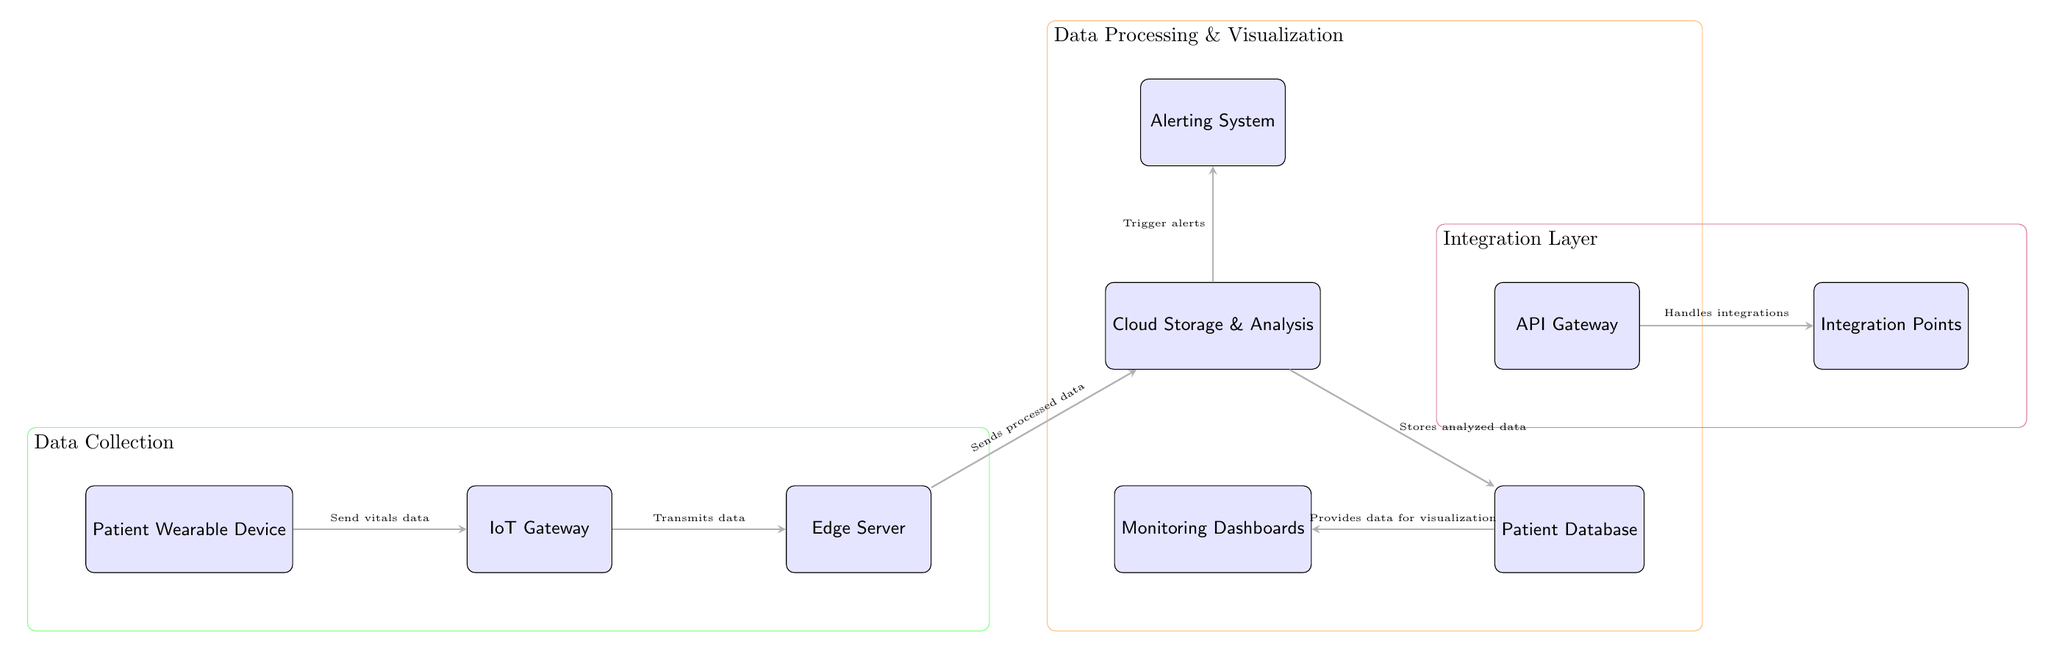What is the first component in the data flow? The first component in the data flow, shown in the diagram, is the "Patient Wearable Device," which initiates the transmission of vitals data.
Answer: Patient Wearable Device How many main components are there in the system architecture? The diagram illustrates a total of 8 main components which include the Patient Wearable Device, IoT Gateway, Edge Server, Cloud Storage & Analysis, Patient Database, Monitoring Dashboards, Alerting System, and API Gateway.
Answer: 8 What do the arrows represent in this diagram? The arrows in the diagram represent the direction of data flow between the different components, indicating how information is transmitted from one point to another within the system architecture.
Answer: Data flow Where does the processed data go after the Edge Server? After the Edge Server, the processed data is sent to the "Cloud Storage & Analysis," where further analysis and storage of the data occur.
Answer: Cloud Storage & Analysis What triggers alerts in the system? Alerts in the system are triggered by the "Cloud Storage & Analysis" component, which monitors the processed data for any critical conditions that require attention.
Answer: Cloud Storage & Analysis Which components are part of the Data Processing & Visualization layer? The components included in the Data Processing & Visualization layer are the "Cloud Storage & Analysis," "Patient Database," "Monitoring Dashboards," and "Alerting System."
Answer: Cloud Storage & Analysis, Patient Database, Monitoring Dashboards, Alerting System What type of system does this diagram represent? This diagram represents a real-time patient monitoring system architecture, designed to capture, process, and visualize patient health data efficiently.
Answer: Real-Time Patient Monitoring System What is the final destination of data in the visualization process? The final destination of data in the visualization process is the "Monitoring Dashboards," where the analyzed data is presented to users for monitoring purposes.
Answer: Monitoring Dashboards 